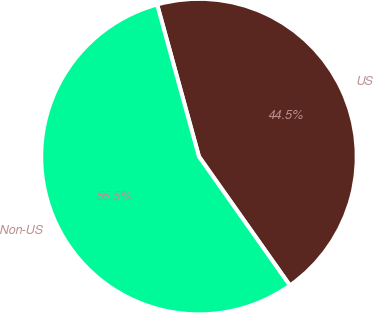<chart> <loc_0><loc_0><loc_500><loc_500><pie_chart><fcel>US<fcel>Non-US<nl><fcel>44.49%<fcel>55.51%<nl></chart> 